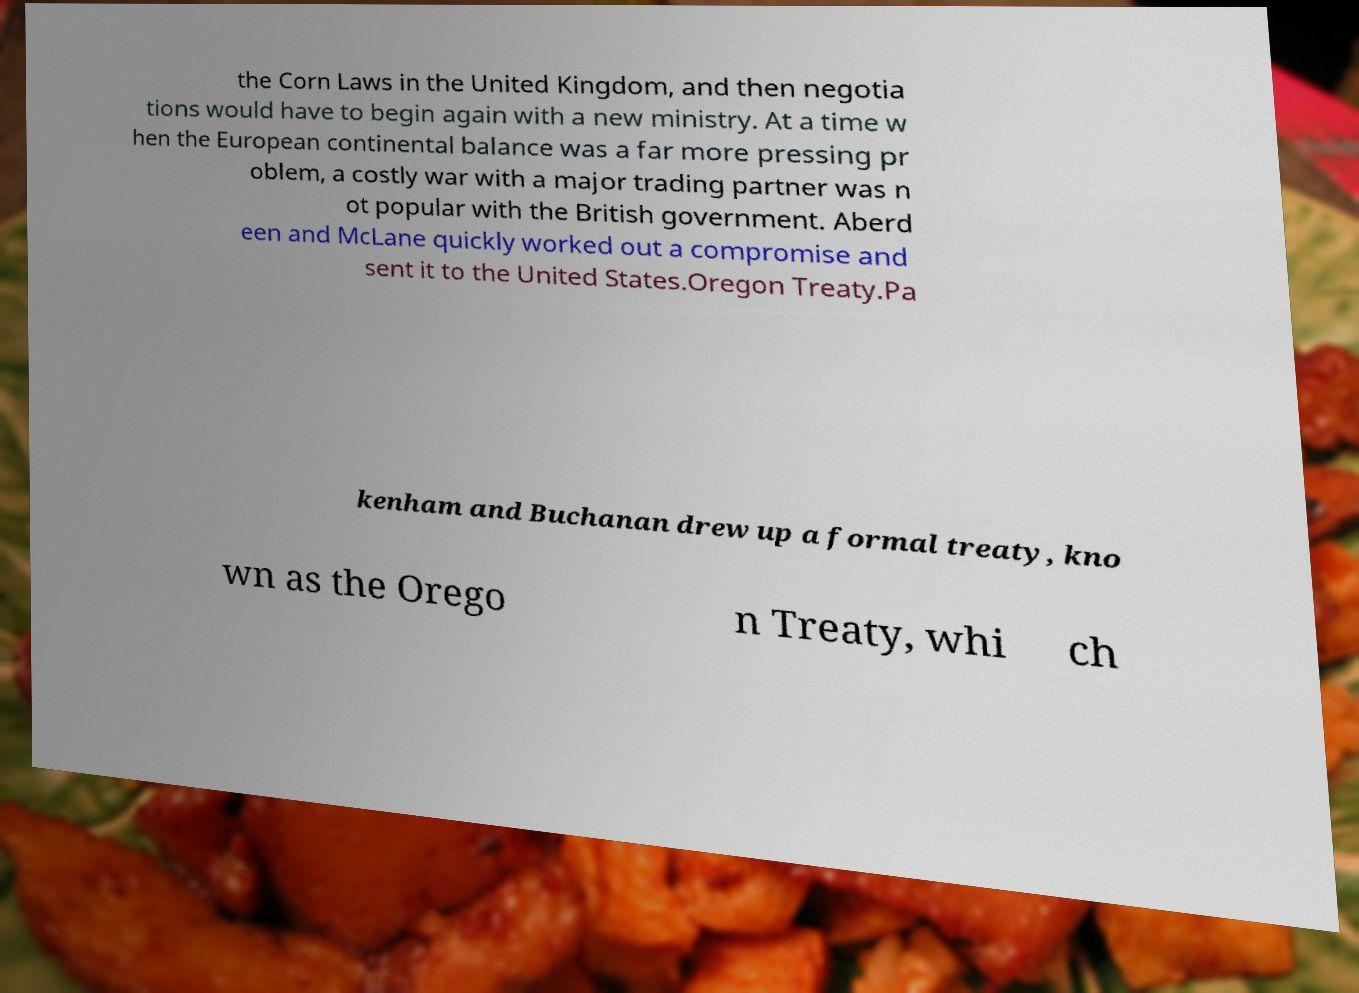What messages or text are displayed in this image? I need them in a readable, typed format. the Corn Laws in the United Kingdom, and then negotia tions would have to begin again with a new ministry. At a time w hen the European continental balance was a far more pressing pr oblem, a costly war with a major trading partner was n ot popular with the British government. Aberd een and McLane quickly worked out a compromise and sent it to the United States.Oregon Treaty.Pa kenham and Buchanan drew up a formal treaty, kno wn as the Orego n Treaty, whi ch 